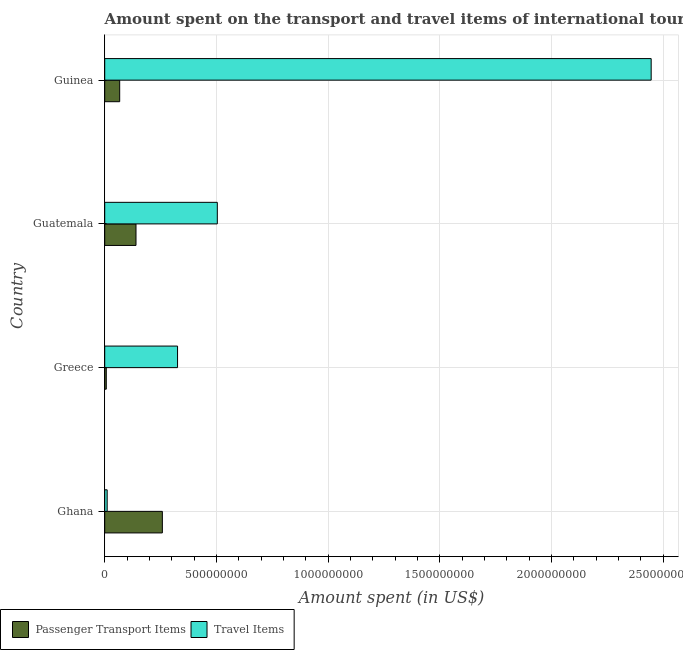How many bars are there on the 4th tick from the bottom?
Give a very brief answer. 2. What is the amount spent in travel items in Greece?
Your answer should be compact. 3.26e+08. Across all countries, what is the maximum amount spent on passenger transport items?
Keep it short and to the point. 2.58e+08. Across all countries, what is the minimum amount spent on passenger transport items?
Make the answer very short. 7.00e+06. In which country was the amount spent on passenger transport items maximum?
Offer a terse response. Ghana. In which country was the amount spent on passenger transport items minimum?
Ensure brevity in your answer.  Greece. What is the total amount spent in travel items in the graph?
Make the answer very short. 3.29e+09. What is the difference between the amount spent in travel items in Ghana and that in Greece?
Provide a short and direct response. -3.15e+08. What is the difference between the amount spent on passenger transport items in Ghana and the amount spent in travel items in Guinea?
Ensure brevity in your answer.  -2.19e+09. What is the average amount spent in travel items per country?
Ensure brevity in your answer.  8.22e+08. What is the difference between the amount spent in travel items and amount spent on passenger transport items in Ghana?
Ensure brevity in your answer.  -2.47e+08. In how many countries, is the amount spent in travel items greater than 1300000000 US$?
Your answer should be very brief. 1. What is the ratio of the amount spent on passenger transport items in Ghana to that in Guinea?
Provide a succinct answer. 3.85. What is the difference between the highest and the second highest amount spent on passenger transport items?
Your answer should be very brief. 1.18e+08. What is the difference between the highest and the lowest amount spent in travel items?
Your answer should be very brief. 2.44e+09. Is the sum of the amount spent on passenger transport items in Greece and Guinea greater than the maximum amount spent in travel items across all countries?
Your answer should be very brief. No. What does the 1st bar from the top in Guinea represents?
Your response must be concise. Travel Items. What does the 1st bar from the bottom in Guinea represents?
Provide a succinct answer. Passenger Transport Items. What is the difference between two consecutive major ticks on the X-axis?
Give a very brief answer. 5.00e+08. Are the values on the major ticks of X-axis written in scientific E-notation?
Offer a terse response. No. Does the graph contain any zero values?
Provide a short and direct response. No. How many legend labels are there?
Give a very brief answer. 2. What is the title of the graph?
Offer a very short reply. Amount spent on the transport and travel items of international tourists visited in 2007. Does "Number of departures" appear as one of the legend labels in the graph?
Make the answer very short. No. What is the label or title of the X-axis?
Offer a very short reply. Amount spent (in US$). What is the label or title of the Y-axis?
Your response must be concise. Country. What is the Amount spent (in US$) of Passenger Transport Items in Ghana?
Your response must be concise. 2.58e+08. What is the Amount spent (in US$) in Travel Items in Ghana?
Offer a very short reply. 1.10e+07. What is the Amount spent (in US$) in Travel Items in Greece?
Make the answer very short. 3.26e+08. What is the Amount spent (in US$) of Passenger Transport Items in Guatemala?
Make the answer very short. 1.40e+08. What is the Amount spent (in US$) in Travel Items in Guatemala?
Your answer should be very brief. 5.04e+08. What is the Amount spent (in US$) of Passenger Transport Items in Guinea?
Provide a succinct answer. 6.70e+07. What is the Amount spent (in US$) of Travel Items in Guinea?
Offer a very short reply. 2.45e+09. Across all countries, what is the maximum Amount spent (in US$) in Passenger Transport Items?
Offer a very short reply. 2.58e+08. Across all countries, what is the maximum Amount spent (in US$) of Travel Items?
Make the answer very short. 2.45e+09. Across all countries, what is the minimum Amount spent (in US$) in Travel Items?
Offer a terse response. 1.10e+07. What is the total Amount spent (in US$) of Passenger Transport Items in the graph?
Make the answer very short. 4.72e+08. What is the total Amount spent (in US$) of Travel Items in the graph?
Offer a terse response. 3.29e+09. What is the difference between the Amount spent (in US$) in Passenger Transport Items in Ghana and that in Greece?
Make the answer very short. 2.51e+08. What is the difference between the Amount spent (in US$) in Travel Items in Ghana and that in Greece?
Your response must be concise. -3.15e+08. What is the difference between the Amount spent (in US$) of Passenger Transport Items in Ghana and that in Guatemala?
Make the answer very short. 1.18e+08. What is the difference between the Amount spent (in US$) of Travel Items in Ghana and that in Guatemala?
Give a very brief answer. -4.93e+08. What is the difference between the Amount spent (in US$) of Passenger Transport Items in Ghana and that in Guinea?
Make the answer very short. 1.91e+08. What is the difference between the Amount spent (in US$) of Travel Items in Ghana and that in Guinea?
Your answer should be very brief. -2.44e+09. What is the difference between the Amount spent (in US$) in Passenger Transport Items in Greece and that in Guatemala?
Give a very brief answer. -1.33e+08. What is the difference between the Amount spent (in US$) in Travel Items in Greece and that in Guatemala?
Keep it short and to the point. -1.78e+08. What is the difference between the Amount spent (in US$) in Passenger Transport Items in Greece and that in Guinea?
Give a very brief answer. -6.00e+07. What is the difference between the Amount spent (in US$) of Travel Items in Greece and that in Guinea?
Offer a terse response. -2.12e+09. What is the difference between the Amount spent (in US$) of Passenger Transport Items in Guatemala and that in Guinea?
Provide a short and direct response. 7.30e+07. What is the difference between the Amount spent (in US$) in Travel Items in Guatemala and that in Guinea?
Offer a terse response. -1.94e+09. What is the difference between the Amount spent (in US$) of Passenger Transport Items in Ghana and the Amount spent (in US$) of Travel Items in Greece?
Ensure brevity in your answer.  -6.80e+07. What is the difference between the Amount spent (in US$) in Passenger Transport Items in Ghana and the Amount spent (in US$) in Travel Items in Guatemala?
Give a very brief answer. -2.46e+08. What is the difference between the Amount spent (in US$) of Passenger Transport Items in Ghana and the Amount spent (in US$) of Travel Items in Guinea?
Provide a succinct answer. -2.19e+09. What is the difference between the Amount spent (in US$) in Passenger Transport Items in Greece and the Amount spent (in US$) in Travel Items in Guatemala?
Ensure brevity in your answer.  -4.97e+08. What is the difference between the Amount spent (in US$) in Passenger Transport Items in Greece and the Amount spent (in US$) in Travel Items in Guinea?
Your response must be concise. -2.44e+09. What is the difference between the Amount spent (in US$) of Passenger Transport Items in Guatemala and the Amount spent (in US$) of Travel Items in Guinea?
Your response must be concise. -2.31e+09. What is the average Amount spent (in US$) of Passenger Transport Items per country?
Your response must be concise. 1.18e+08. What is the average Amount spent (in US$) in Travel Items per country?
Offer a very short reply. 8.22e+08. What is the difference between the Amount spent (in US$) in Passenger Transport Items and Amount spent (in US$) in Travel Items in Ghana?
Make the answer very short. 2.47e+08. What is the difference between the Amount spent (in US$) in Passenger Transport Items and Amount spent (in US$) in Travel Items in Greece?
Provide a short and direct response. -3.19e+08. What is the difference between the Amount spent (in US$) of Passenger Transport Items and Amount spent (in US$) of Travel Items in Guatemala?
Provide a short and direct response. -3.64e+08. What is the difference between the Amount spent (in US$) in Passenger Transport Items and Amount spent (in US$) in Travel Items in Guinea?
Offer a very short reply. -2.38e+09. What is the ratio of the Amount spent (in US$) in Passenger Transport Items in Ghana to that in Greece?
Offer a very short reply. 36.86. What is the ratio of the Amount spent (in US$) of Travel Items in Ghana to that in Greece?
Make the answer very short. 0.03. What is the ratio of the Amount spent (in US$) of Passenger Transport Items in Ghana to that in Guatemala?
Make the answer very short. 1.84. What is the ratio of the Amount spent (in US$) of Travel Items in Ghana to that in Guatemala?
Your answer should be very brief. 0.02. What is the ratio of the Amount spent (in US$) in Passenger Transport Items in Ghana to that in Guinea?
Your response must be concise. 3.85. What is the ratio of the Amount spent (in US$) in Travel Items in Ghana to that in Guinea?
Your response must be concise. 0. What is the ratio of the Amount spent (in US$) in Travel Items in Greece to that in Guatemala?
Provide a succinct answer. 0.65. What is the ratio of the Amount spent (in US$) of Passenger Transport Items in Greece to that in Guinea?
Ensure brevity in your answer.  0.1. What is the ratio of the Amount spent (in US$) of Travel Items in Greece to that in Guinea?
Give a very brief answer. 0.13. What is the ratio of the Amount spent (in US$) of Passenger Transport Items in Guatemala to that in Guinea?
Make the answer very short. 2.09. What is the ratio of the Amount spent (in US$) of Travel Items in Guatemala to that in Guinea?
Give a very brief answer. 0.21. What is the difference between the highest and the second highest Amount spent (in US$) of Passenger Transport Items?
Provide a short and direct response. 1.18e+08. What is the difference between the highest and the second highest Amount spent (in US$) of Travel Items?
Make the answer very short. 1.94e+09. What is the difference between the highest and the lowest Amount spent (in US$) of Passenger Transport Items?
Make the answer very short. 2.51e+08. What is the difference between the highest and the lowest Amount spent (in US$) of Travel Items?
Your answer should be compact. 2.44e+09. 